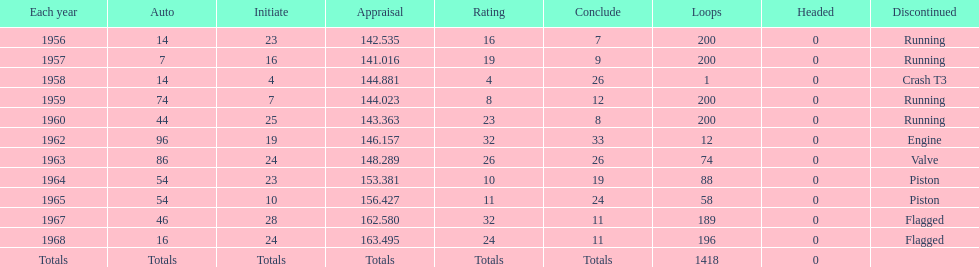How many times did he finish all 200 laps? 4. 